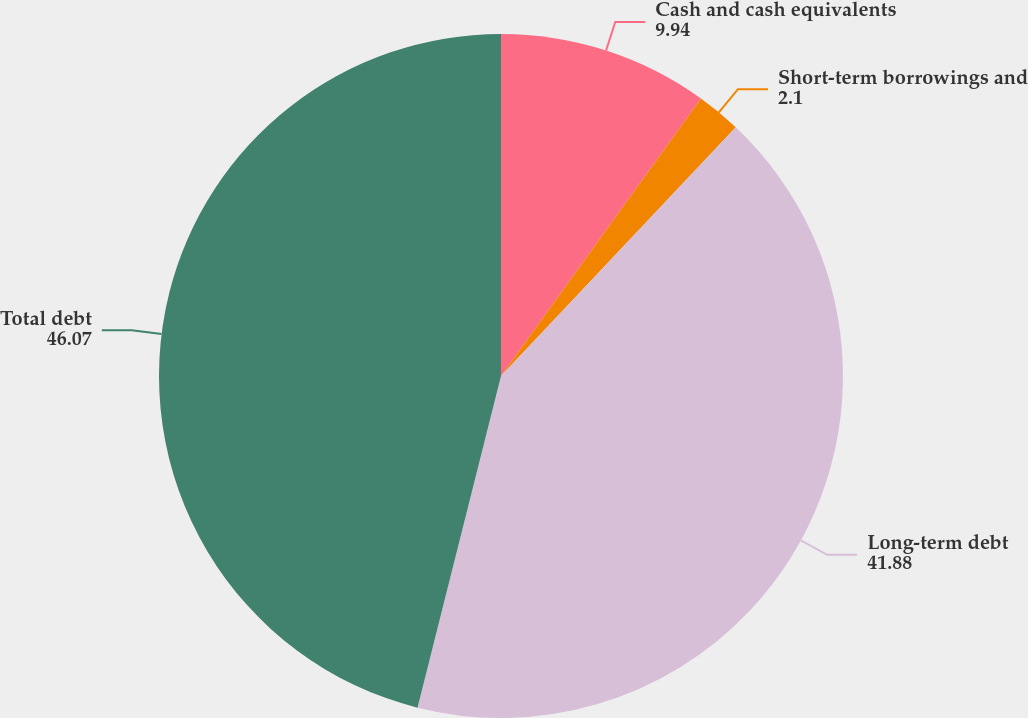<chart> <loc_0><loc_0><loc_500><loc_500><pie_chart><fcel>Cash and cash equivalents<fcel>Short-term borrowings and<fcel>Long-term debt<fcel>Total debt<nl><fcel>9.94%<fcel>2.1%<fcel>41.88%<fcel>46.07%<nl></chart> 